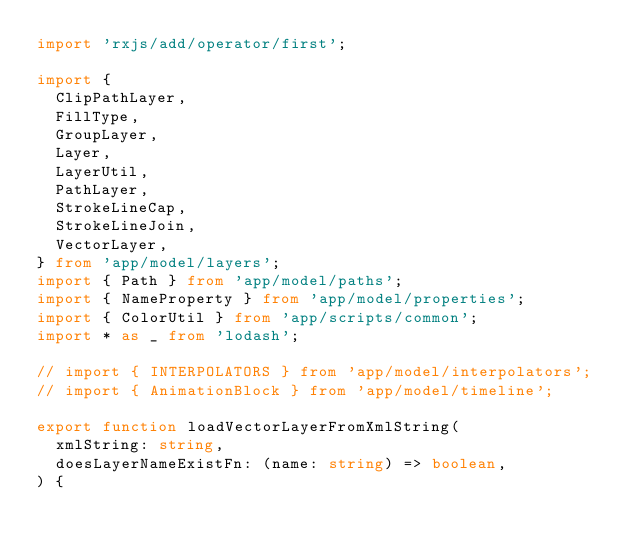Convert code to text. <code><loc_0><loc_0><loc_500><loc_500><_TypeScript_>import 'rxjs/add/operator/first';

import {
  ClipPathLayer,
  FillType,
  GroupLayer,
  Layer,
  LayerUtil,
  PathLayer,
  StrokeLineCap,
  StrokeLineJoin,
  VectorLayer,
} from 'app/model/layers';
import { Path } from 'app/model/paths';
import { NameProperty } from 'app/model/properties';
import { ColorUtil } from 'app/scripts/common';
import * as _ from 'lodash';

// import { INTERPOLATORS } from 'app/model/interpolators';
// import { AnimationBlock } from 'app/model/timeline';

export function loadVectorLayerFromXmlString(
  xmlString: string,
  doesLayerNameExistFn: (name: string) => boolean,
) {</code> 